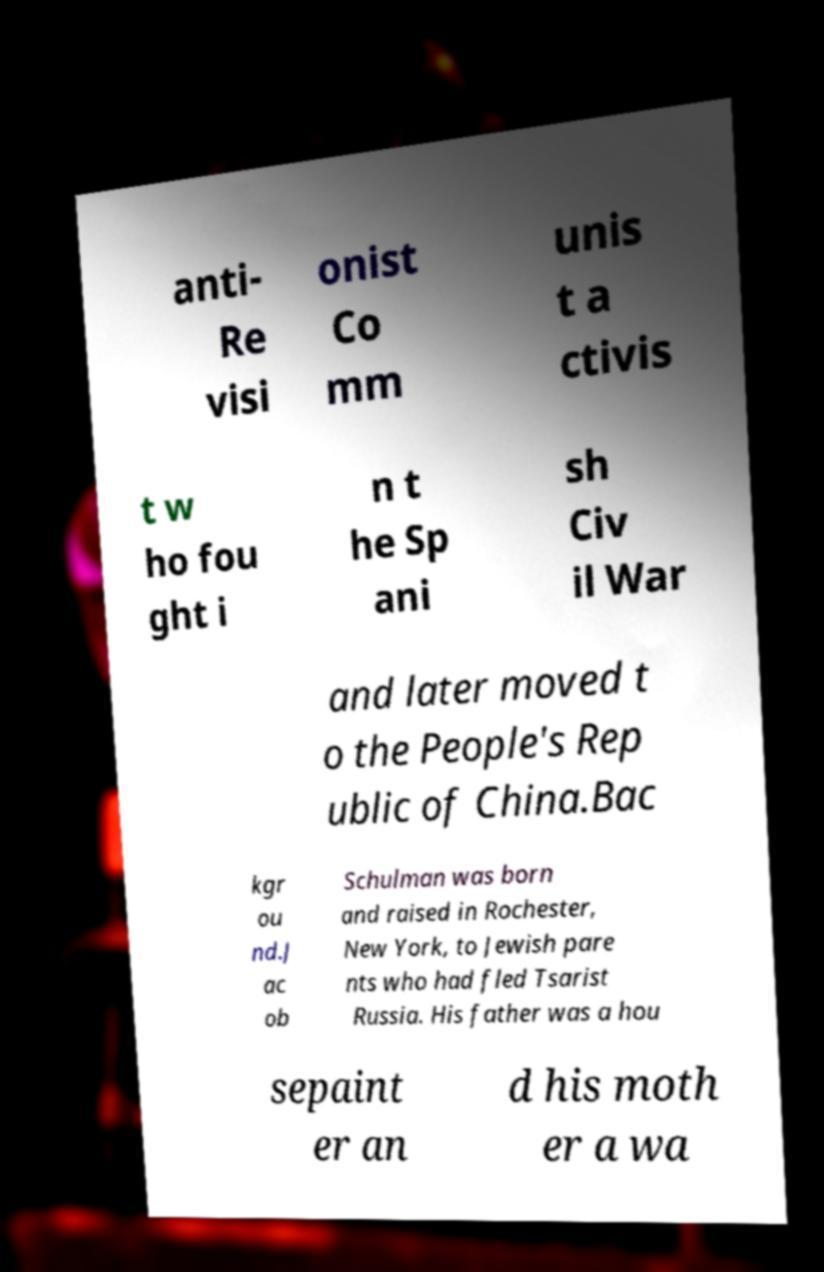Please identify and transcribe the text found in this image. anti- Re visi onist Co mm unis t a ctivis t w ho fou ght i n t he Sp ani sh Civ il War and later moved t o the People's Rep ublic of China.Bac kgr ou nd.J ac ob Schulman was born and raised in Rochester, New York, to Jewish pare nts who had fled Tsarist Russia. His father was a hou sepaint er an d his moth er a wa 